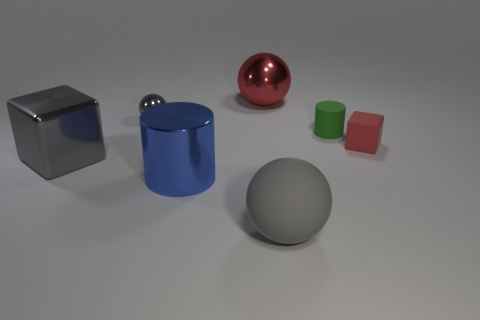There is a gray ball to the left of the cylinder in front of the green rubber object; how big is it?
Your answer should be compact. Small. What number of large things are either gray shiny things or green things?
Your answer should be compact. 1. What number of other things are the same color as the big shiny sphere?
Your response must be concise. 1. There is a ball on the left side of the red shiny thing; is its size the same as the red object that is to the right of the small green matte cylinder?
Offer a terse response. Yes. Do the big cylinder and the small thing to the left of the big blue cylinder have the same material?
Give a very brief answer. Yes. Is the number of objects behind the tiny matte cylinder greater than the number of gray metal objects behind the big red ball?
Keep it short and to the point. Yes. There is a block to the left of the ball in front of the small gray shiny thing; what is its color?
Offer a very short reply. Gray. What number of spheres are shiny things or cyan matte objects?
Keep it short and to the point. 2. What number of things are right of the gray metallic ball and behind the tiny rubber cylinder?
Keep it short and to the point. 1. There is a cube to the right of the large rubber object; what color is it?
Your answer should be compact. Red. 